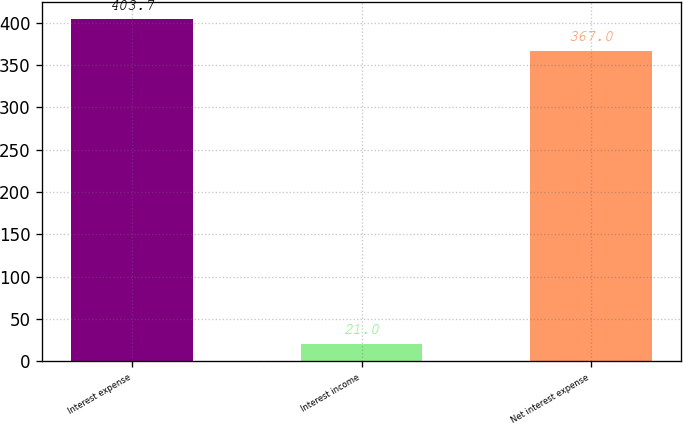Convert chart to OTSL. <chart><loc_0><loc_0><loc_500><loc_500><bar_chart><fcel>Interest expense<fcel>Interest income<fcel>Net interest expense<nl><fcel>403.7<fcel>21<fcel>367<nl></chart> 